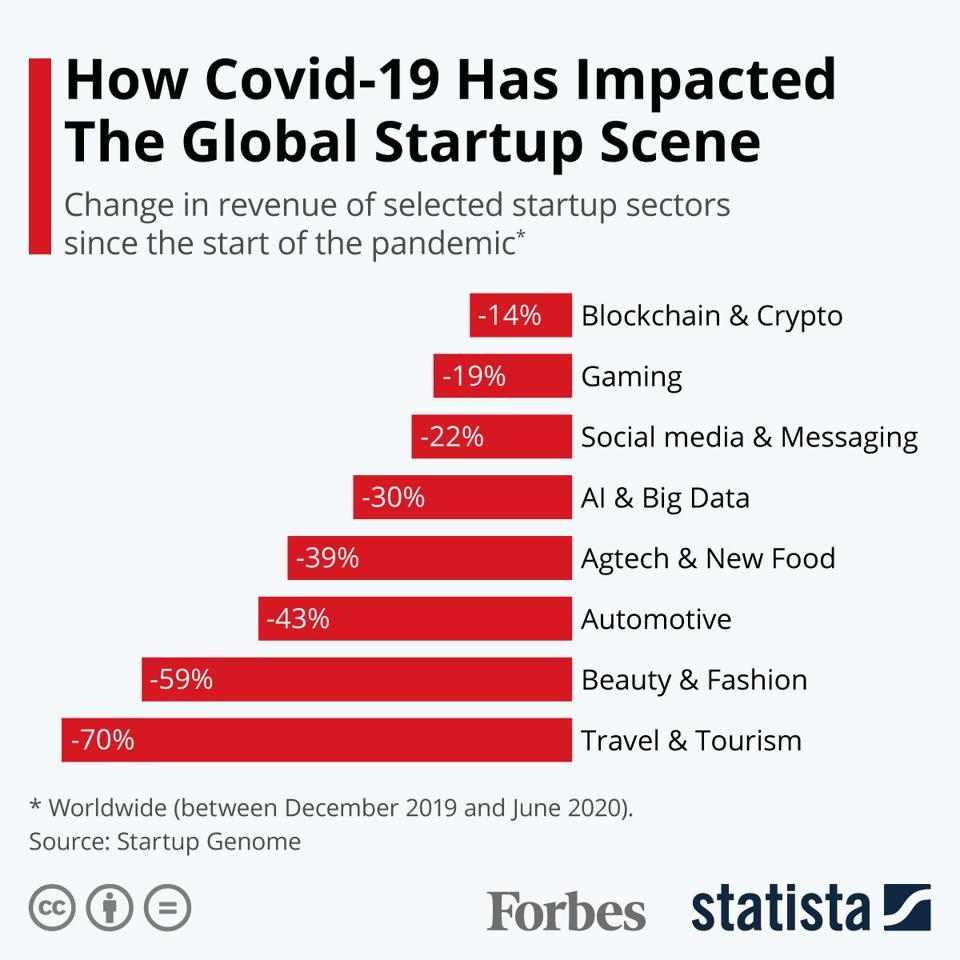Specify some key components in this picture. Travel & Tourism had the most significant change in revenue among startups. 